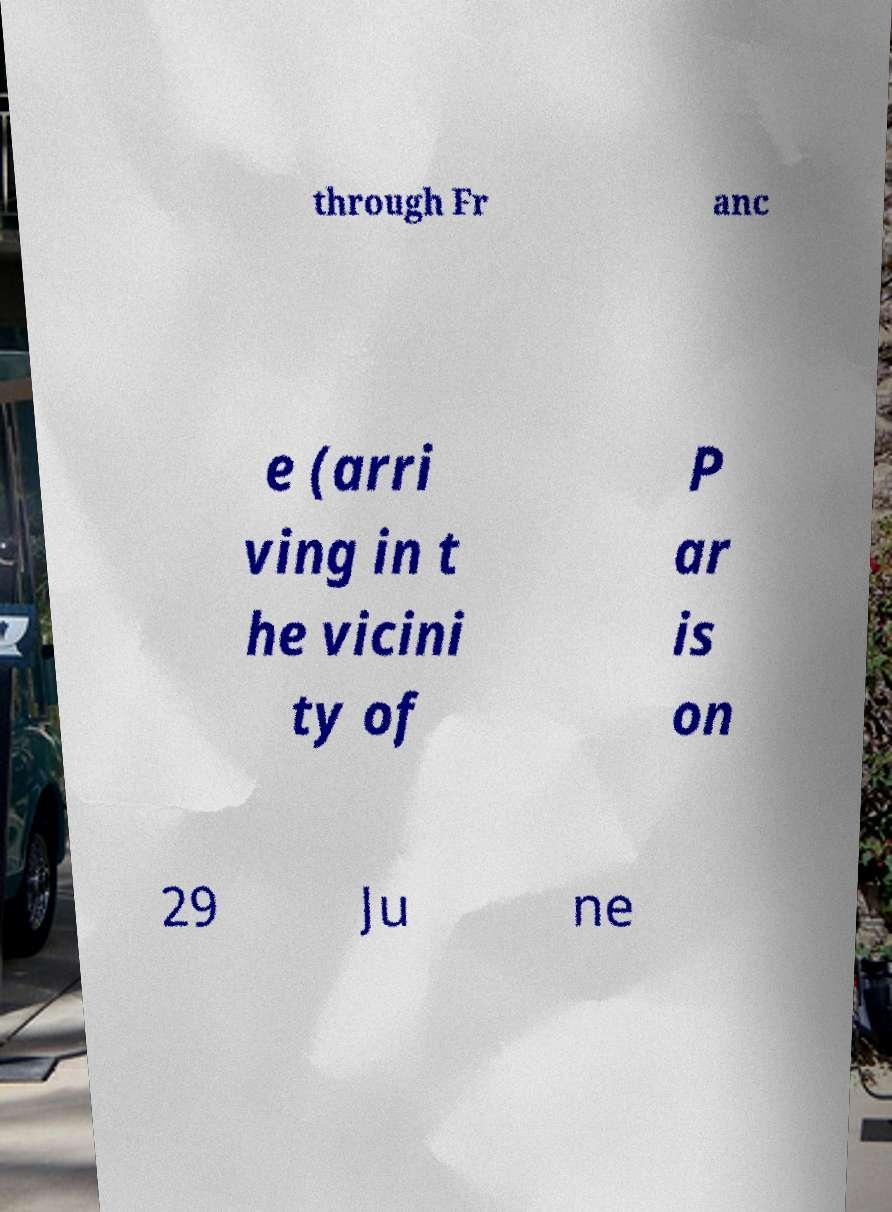Please identify and transcribe the text found in this image. through Fr anc e (arri ving in t he vicini ty of P ar is on 29 Ju ne 